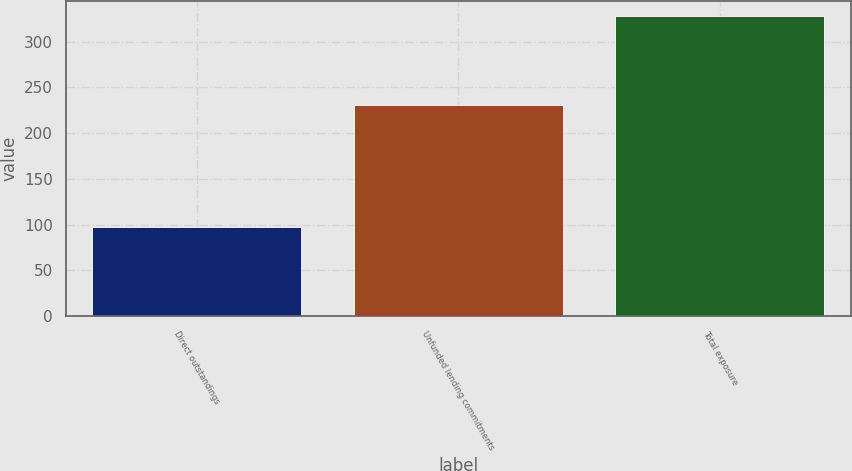Convert chart. <chart><loc_0><loc_0><loc_500><loc_500><bar_chart><fcel>Direct outstandings<fcel>Unfunded lending commitments<fcel>Total exposure<nl><fcel>97<fcel>231<fcel>328<nl></chart> 